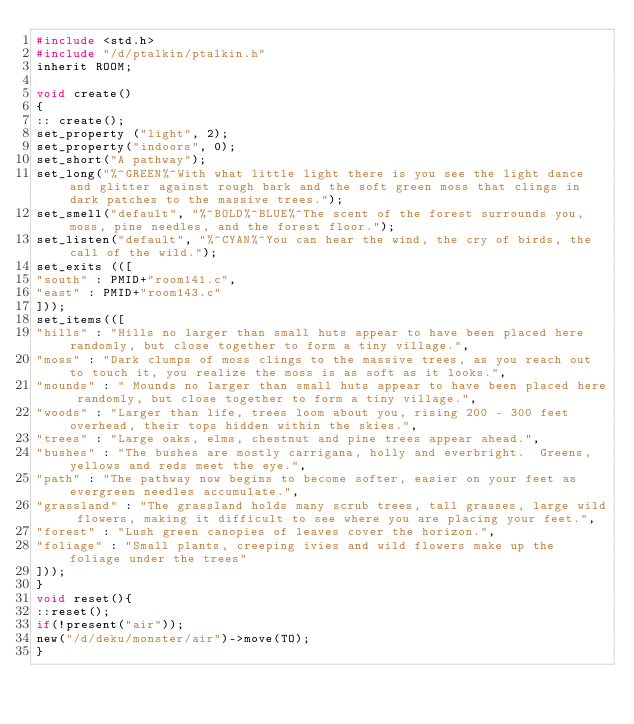<code> <loc_0><loc_0><loc_500><loc_500><_C_>#include <std.h>
#include "/d/ptalkin/ptalkin.h"
inherit ROOM;

void create()
{
:: create();
set_property ("light", 2);
set_property("indoors", 0);
set_short("A pathway");
set_long("%^GREEN%^With what little light there is you see the light dance and glitter against rough bark and the soft green moss that clings in dark patches to the massive trees.");
set_smell("default", "%^BOLD%^BLUE%^The scent of the forest surrounds you, moss, pine needles, and the forest floor.");
set_listen("default", "%^CYAN%^You can hear the wind, the cry of birds, the call of the wild.");
set_exits (([
"south" : PMID+"room141.c",
"east" : PMID+"room143.c"
]));
set_items(([
"hills" : "Hills no larger than small huts appear to have been placed here randomly, but close together to form a tiny village.",
"moss" : "Dark clumps of moss clings to the massive trees, as you reach out to touch it, you realize the moss is as soft as it looks.",
"mounds" : " Mounds no larger than small huts appear to have been placed here randomly, but close together to form a tiny village.",
"woods" : "Larger than life, trees loom about you, rising 200 - 300 feet overhead, their tops hidden within the skies.",
"trees" : "Large oaks, elms, chestnut and pine trees appear ahead.",
"bushes" : "The bushes are mostly carrigana, holly and everbright.  Greens, yellows and reds meet the eye.",
"path" : "The pathway now begins to become softer, easier on your feet as evergreen needles accumulate.",
"grassland" : "The grassland holds many scrub trees, tall grasses, large wild flowers, making it difficult to see where you are placing your feet.",
"forest" : "Lush green canopies of leaves cover the horizon.",
"foliage" : "Small plants, creeping ivies and wild flowers make up the foliage under the trees"
]));
}
void reset(){
::reset();
if(!present("air"));
new("/d/deku/monster/air")->move(TO);
}
</code> 